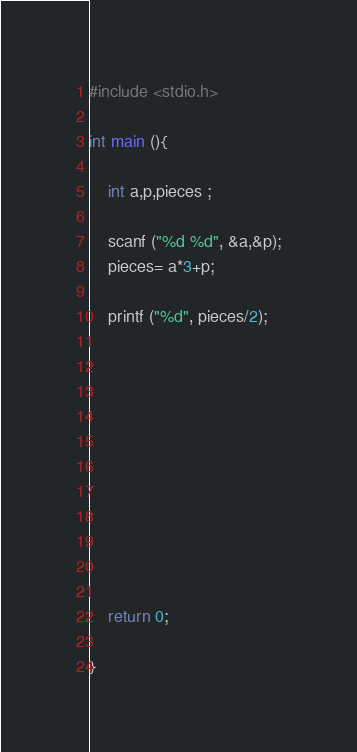Convert code to text. <code><loc_0><loc_0><loc_500><loc_500><_C_>#include <stdio.h>

int main (){

    int a,p,pieces ;

    scanf ("%d %d", &a,&p);
    pieces= a*3+p;

    printf ("%d", pieces/2);











    return 0;

}
</code> 